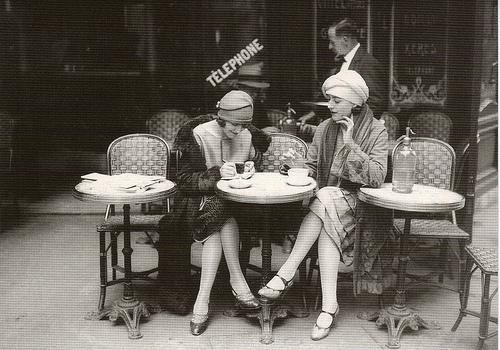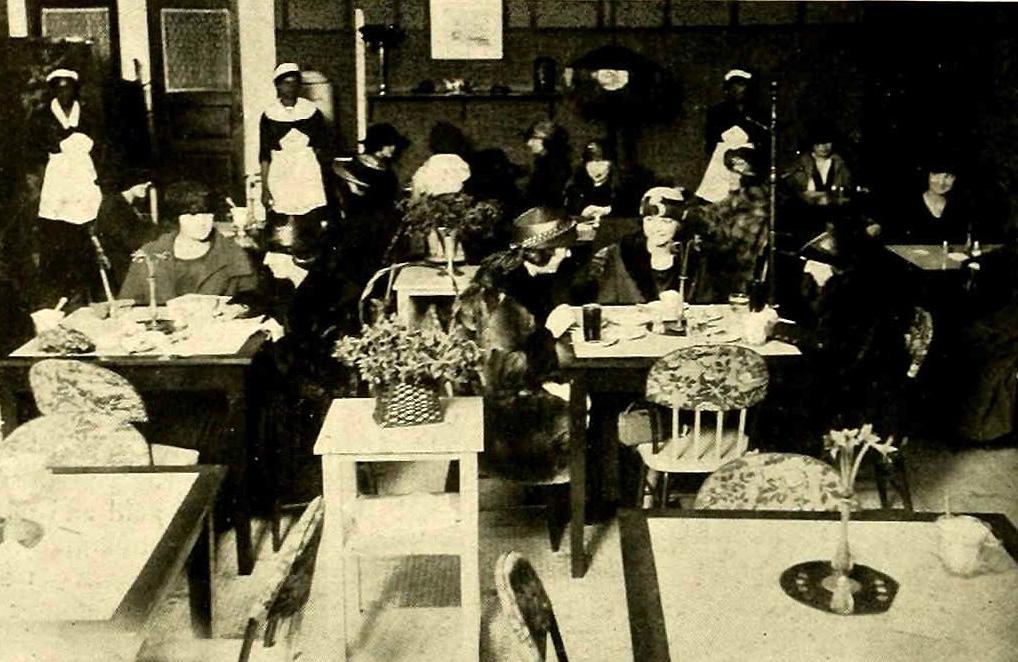The first image is the image on the left, the second image is the image on the right. Assess this claim about the two images: "The left image shows two people seated at a small table set with coffee cups, and a person standing behind them.". Correct or not? Answer yes or no. Yes. The first image is the image on the left, the second image is the image on the right. Examine the images to the left and right. Is the description "One black and white photo and one sepia photo." accurate? Answer yes or no. Yes. 